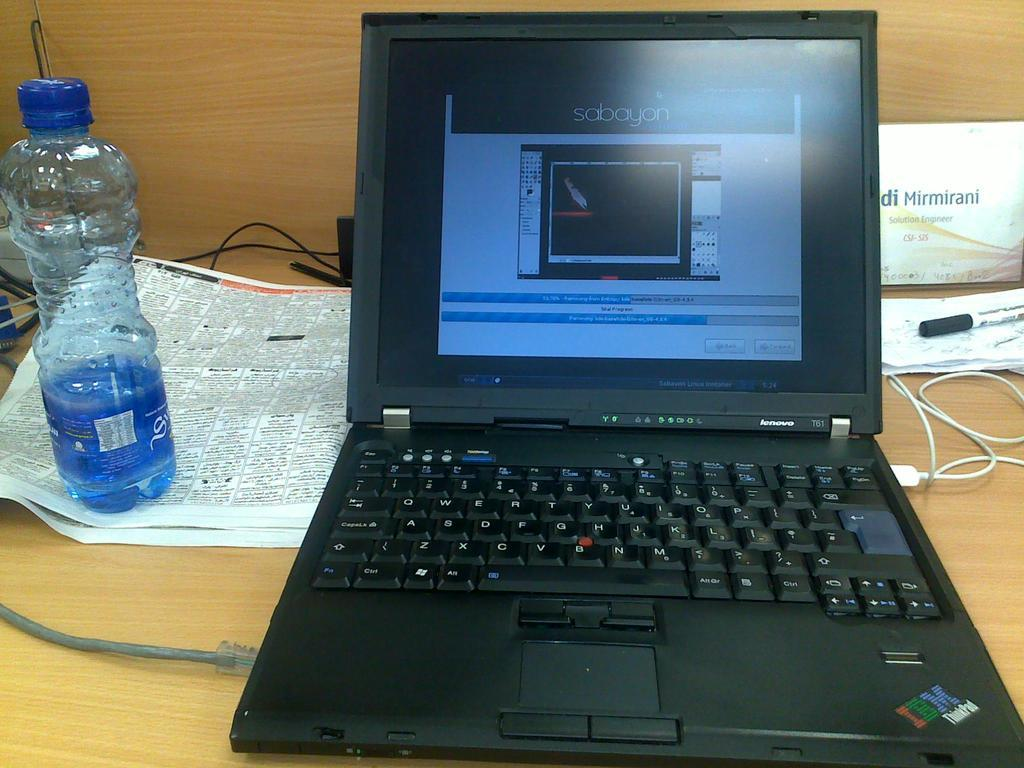What electronic device is on the table in the image? There is a laptop on the table in the image. What other objects can be seen on the table? There is a bottle, a paper, a marker, and a cable on the table. Where is the kitty playing with the key in the image? There is no kitty or key present in the image. What type of war is depicted in the image? There is no depiction of war in the image; it features a laptop and other objects on a table. 